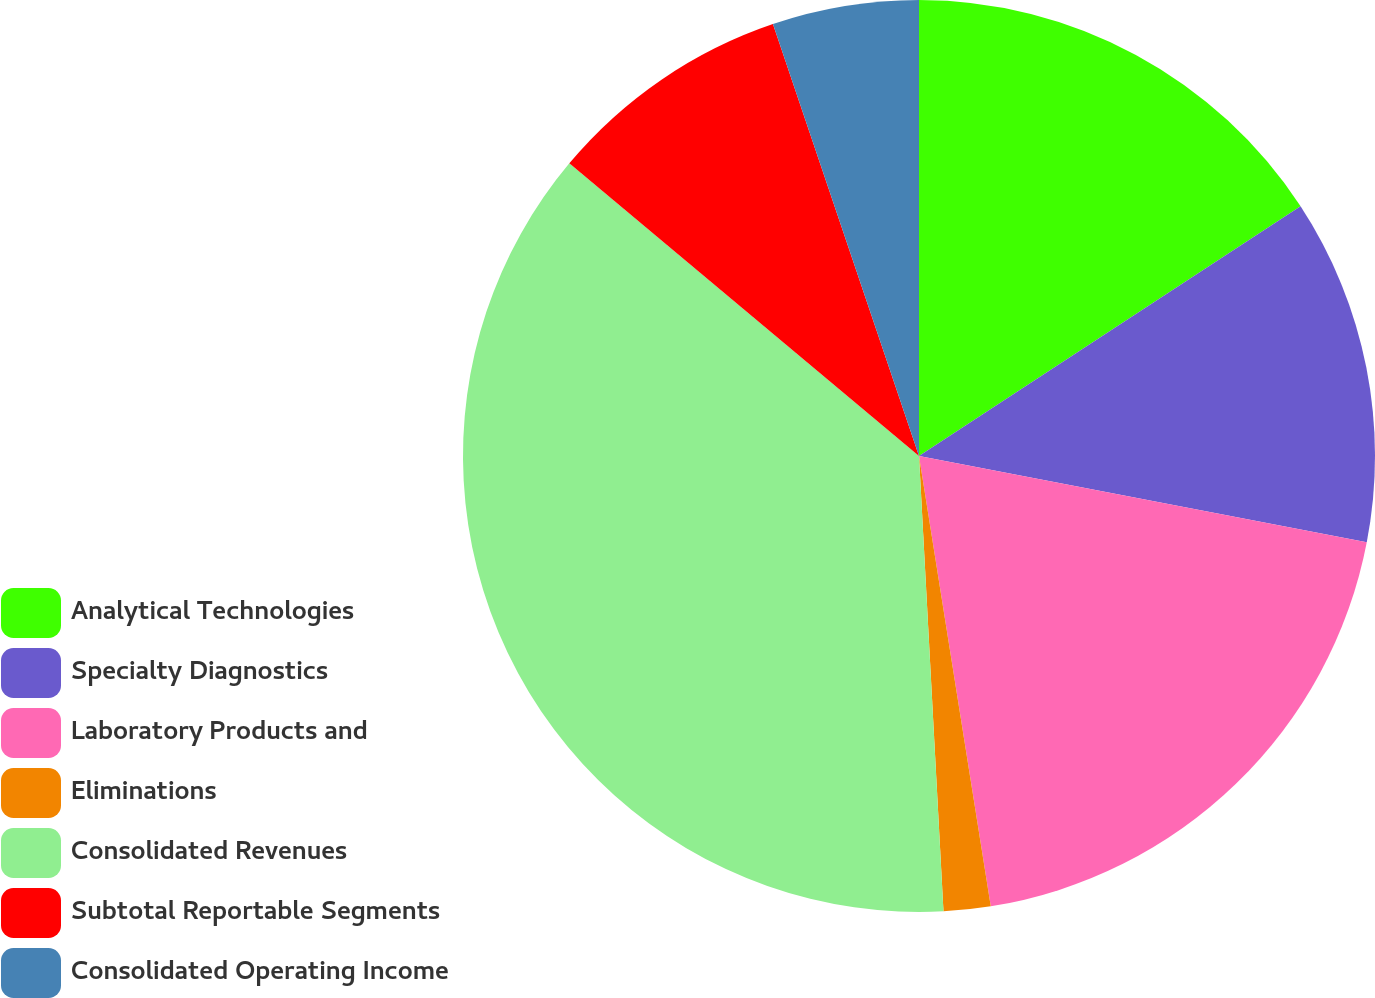Convert chart to OTSL. <chart><loc_0><loc_0><loc_500><loc_500><pie_chart><fcel>Analytical Technologies<fcel>Specialty Diagnostics<fcel>Laboratory Products and<fcel>Eliminations<fcel>Consolidated Revenues<fcel>Subtotal Reportable Segments<fcel>Consolidated Operating Income<nl><fcel>15.78%<fcel>12.25%<fcel>19.46%<fcel>1.66%<fcel>36.95%<fcel>8.72%<fcel>5.19%<nl></chart> 